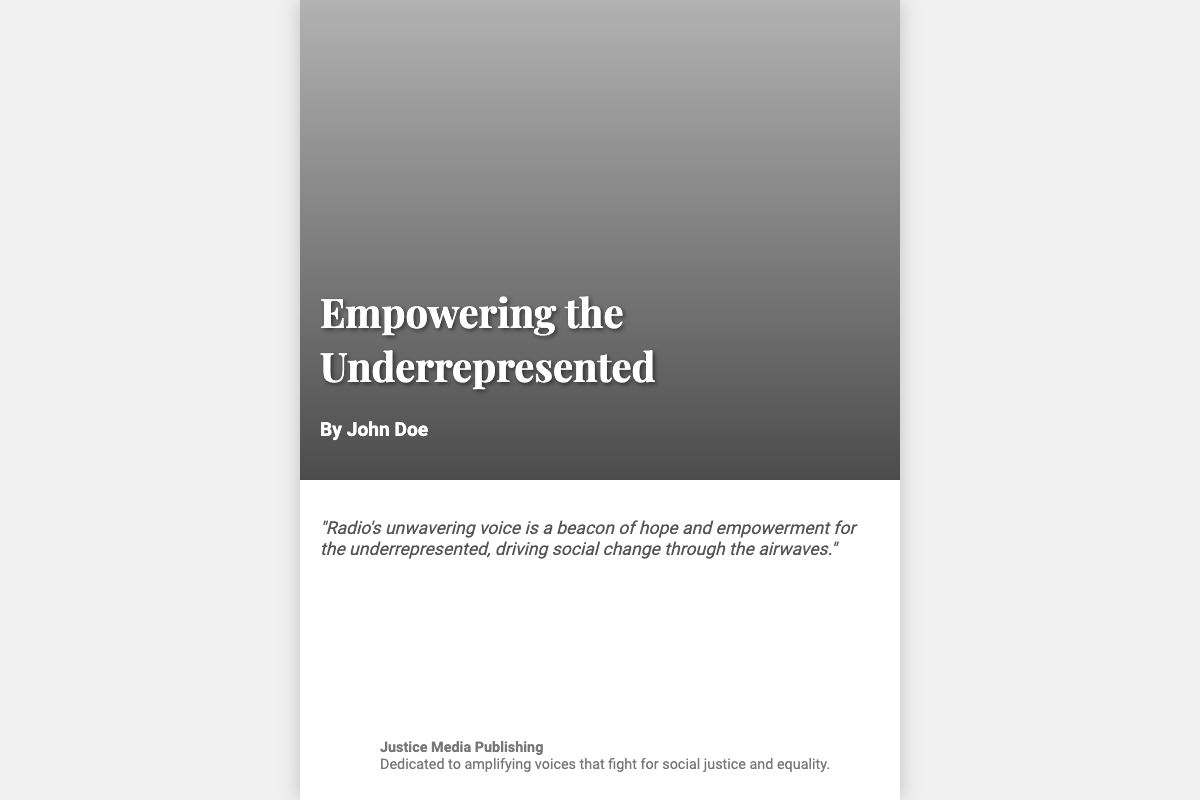What is the title of the book? The title is displayed prominently on the cover of the book.
Answer: Empowering the Underrepresented Who is the author of the book? The author's name is listed below the title on the cover.
Answer: John Doe What themes do the symbols represent on the cover? The symbols like scales and raised fists relate to social justice themes visually represented on the cover.
Answer: Justice What is the publisher's name? The publisher's name is mentioned in the information section at the bottom of the cover.
Answer: Justice Media Publishing What does the quote on the cover emphasize? The quote reflects the role of radio in advocating for social change for the underrepresented.
Answer: Empowerment What type of media is highlighted in the book? The cover indicates the importance of a specific media format relevant to social issues.
Answer: Radio What is the background of the book cover? The backdrop of the cover features historical imagery related to social movements.
Answer: Historical protest photos What is the purpose of the publisher mentioned on the cover? The publisher's description indicates their mission regarding social justice.
Answer: Amplifying voices for social justice What color scheme is predominant on the book cover? The cover features a specific kind of visual appeal through colors used in elements.
Answer: Vibrant and colorful 